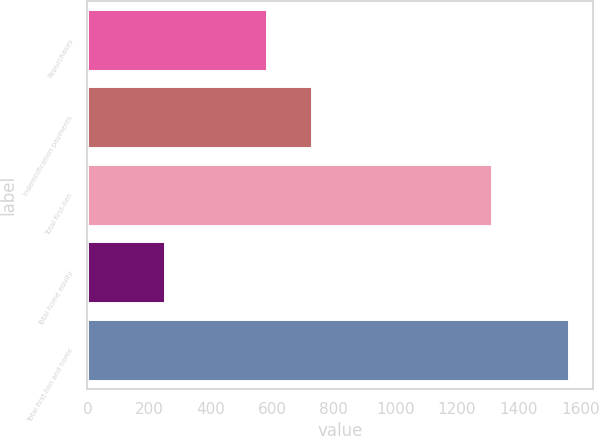Convert chart. <chart><loc_0><loc_0><loc_500><loc_500><bar_chart><fcel>Repurchases<fcel>Indemnification payments<fcel>Total first-lien<fcel>Total home equity<fcel>Total first-lien and home<nl><fcel>583<fcel>730<fcel>1313<fcel>251<fcel>1564<nl></chart> 